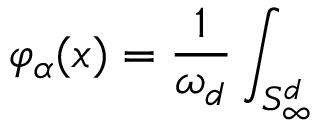Convert formula to latex. <formula><loc_0><loc_0><loc_500><loc_500>\varphi _ { \alpha } ( x ) = \frac { 1 } { \omega _ { d } } \int _ { S _ { \infty } ^ { d } }</formula> 